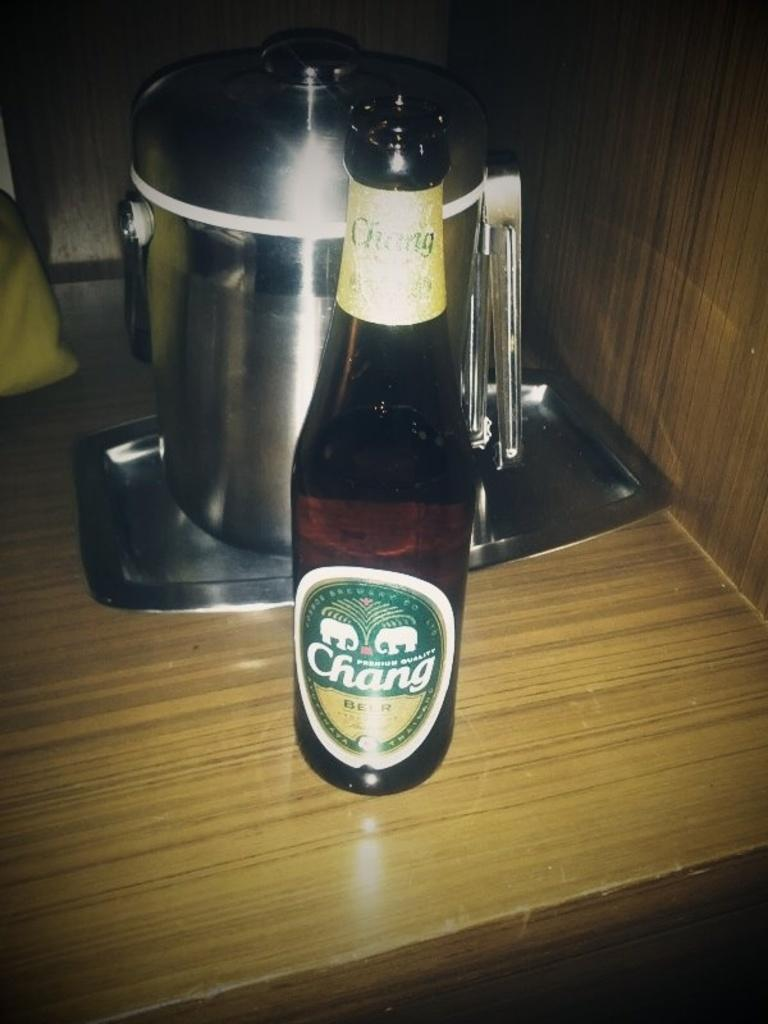<image>
Present a compact description of the photo's key features. A bottle of Chang beer in front of a metal container is on a fake wooden counter top. 